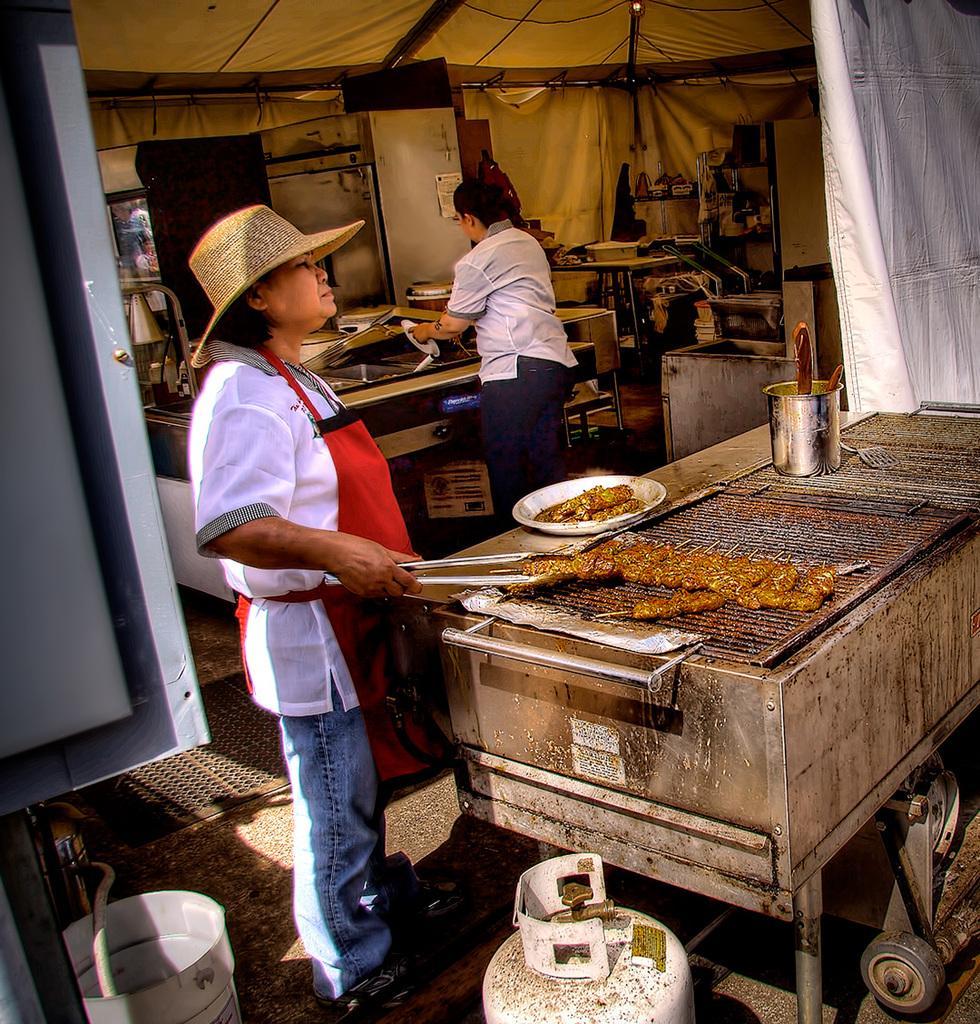Describe this image in one or two sentences. On the right side there is a grill. Also there is a food item. On the grill there is a bowl with some food item, spoon and a vessel with spoons. Near to that a lady is wearing a hat and a apron is holding a tongs. Near to the girl there is a gas cylinder and a bucket.. Also there is a lady and a gas stove in the background. Also there are some other items in the background. 